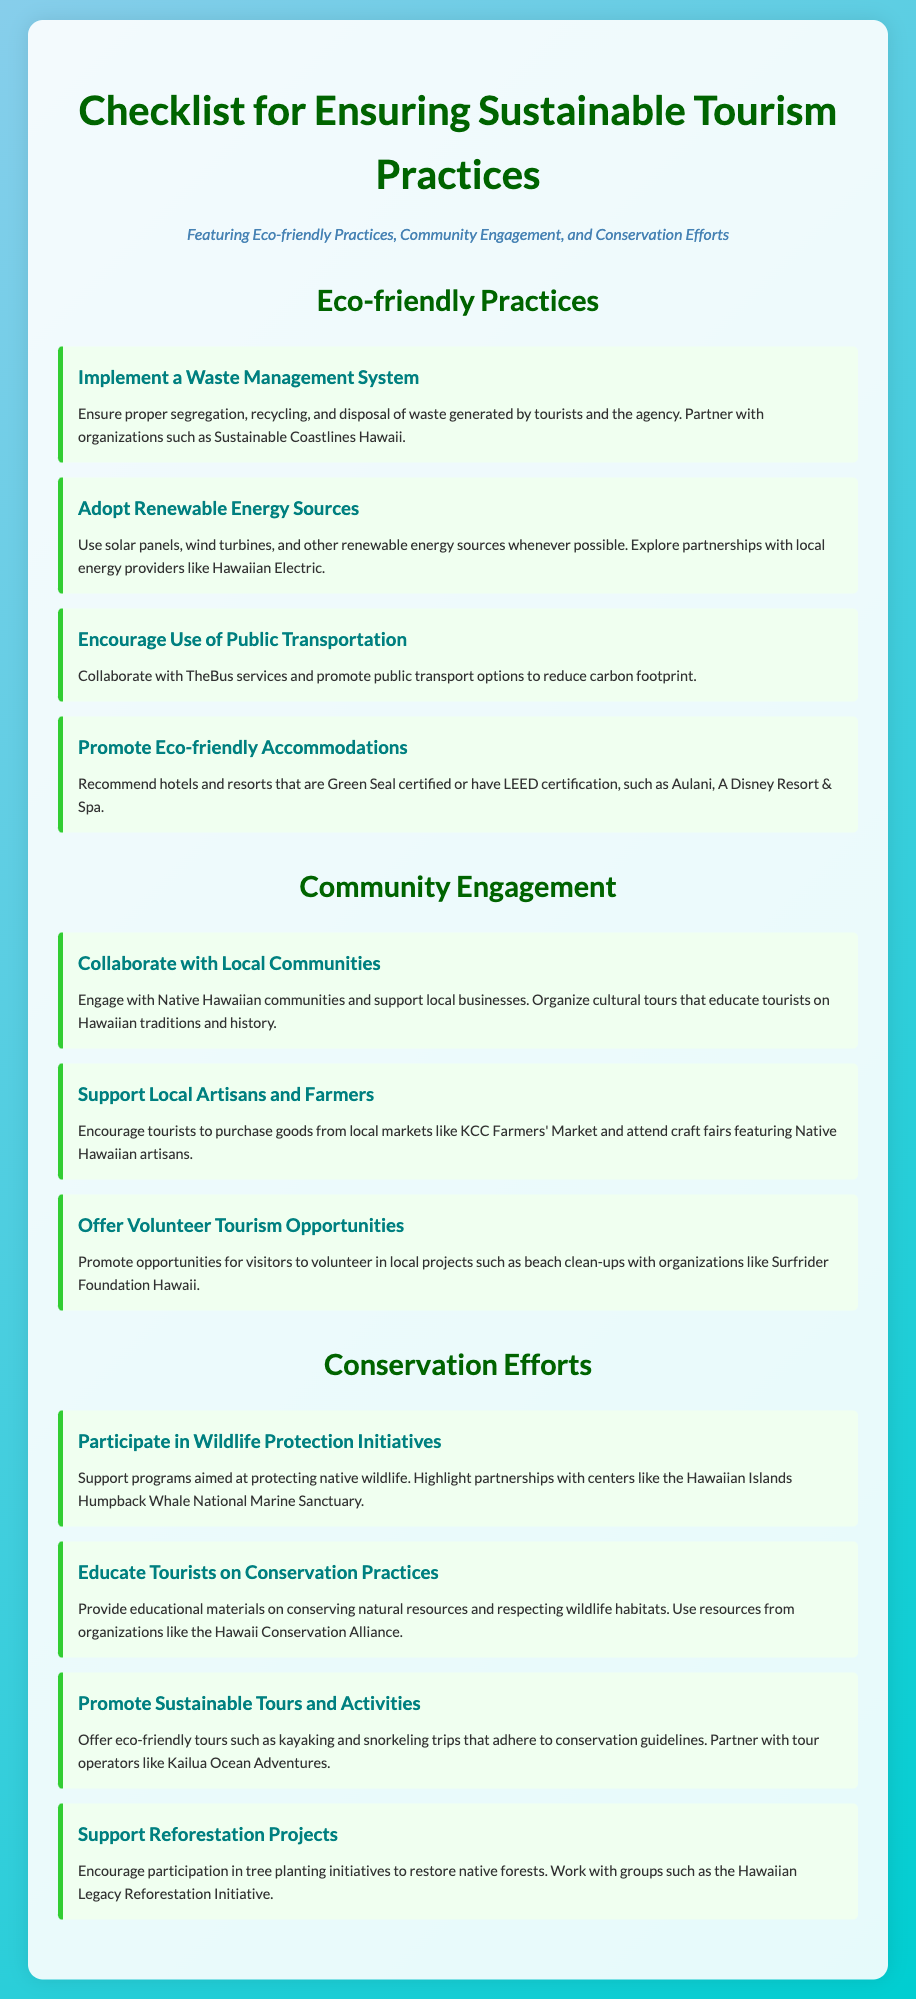What is the title of the checklist? The title is prominently displayed at the top of the document.
Answer: Checklist for Ensuring Sustainable Tourism Practices What section discusses wildlife protection? The document contains several sections, one of which focuses on conservation efforts including wildlife protection.
Answer: Conservation Efforts Name one organization mentioned for waste management. One of the checklist items refers to a partnership for waste management, including a specific organization.
Answer: Sustainable Coastlines Hawaii How many checklist items are under Eco-friendly Practices? The number of items in each section is listed under the respective headings in the document.
Answer: Four Which local market is encouraged for supporting local artisans? The document provides examples of places where tourists can support local artisans, including markets.
Answer: KCC Farmers' Market What is one of the recommended eco-friendly accommodations? The checklist recommends specific accommodations as part of promoting eco-friendly practices.
Answer: Aulani, A Disney Resort & Spa What type of tourism opportunity is promoted in the Community Engagement section? The document includes initiatives encouraging specific actions tourists can take related to local community involvement.
Answer: Volunteer Tourism Opportunities How many items are listed under Conservation Efforts? The total number of items in the section regarding conservation is provided in a simple count of the checklist items.
Answer: Four 